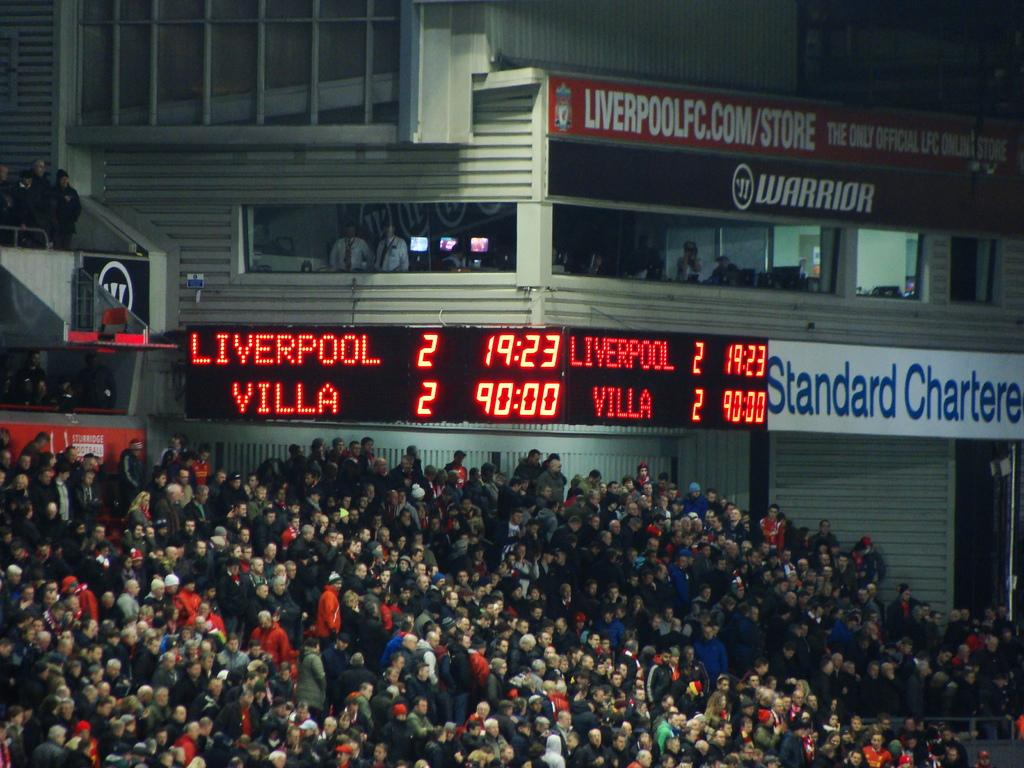<image>
Write a terse but informative summary of the picture. A scoreboard at Anfield football ground tells us Liverpool is drawing 0-0 with Aston Villa as the crowd below it watch the match. 